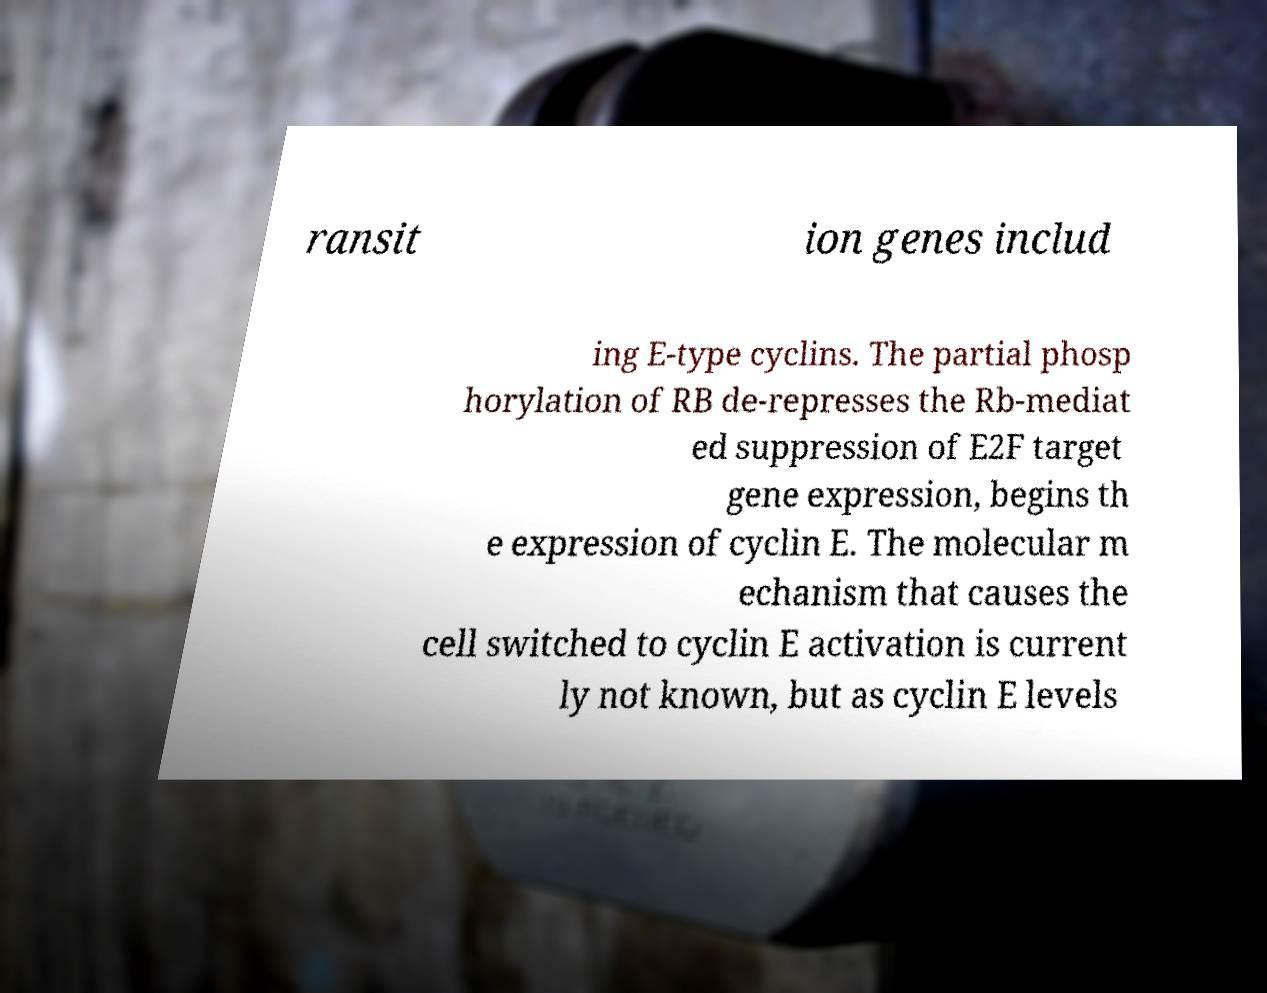I need the written content from this picture converted into text. Can you do that? ransit ion genes includ ing E-type cyclins. The partial phosp horylation of RB de-represses the Rb-mediat ed suppression of E2F target gene expression, begins th e expression of cyclin E. The molecular m echanism that causes the cell switched to cyclin E activation is current ly not known, but as cyclin E levels 